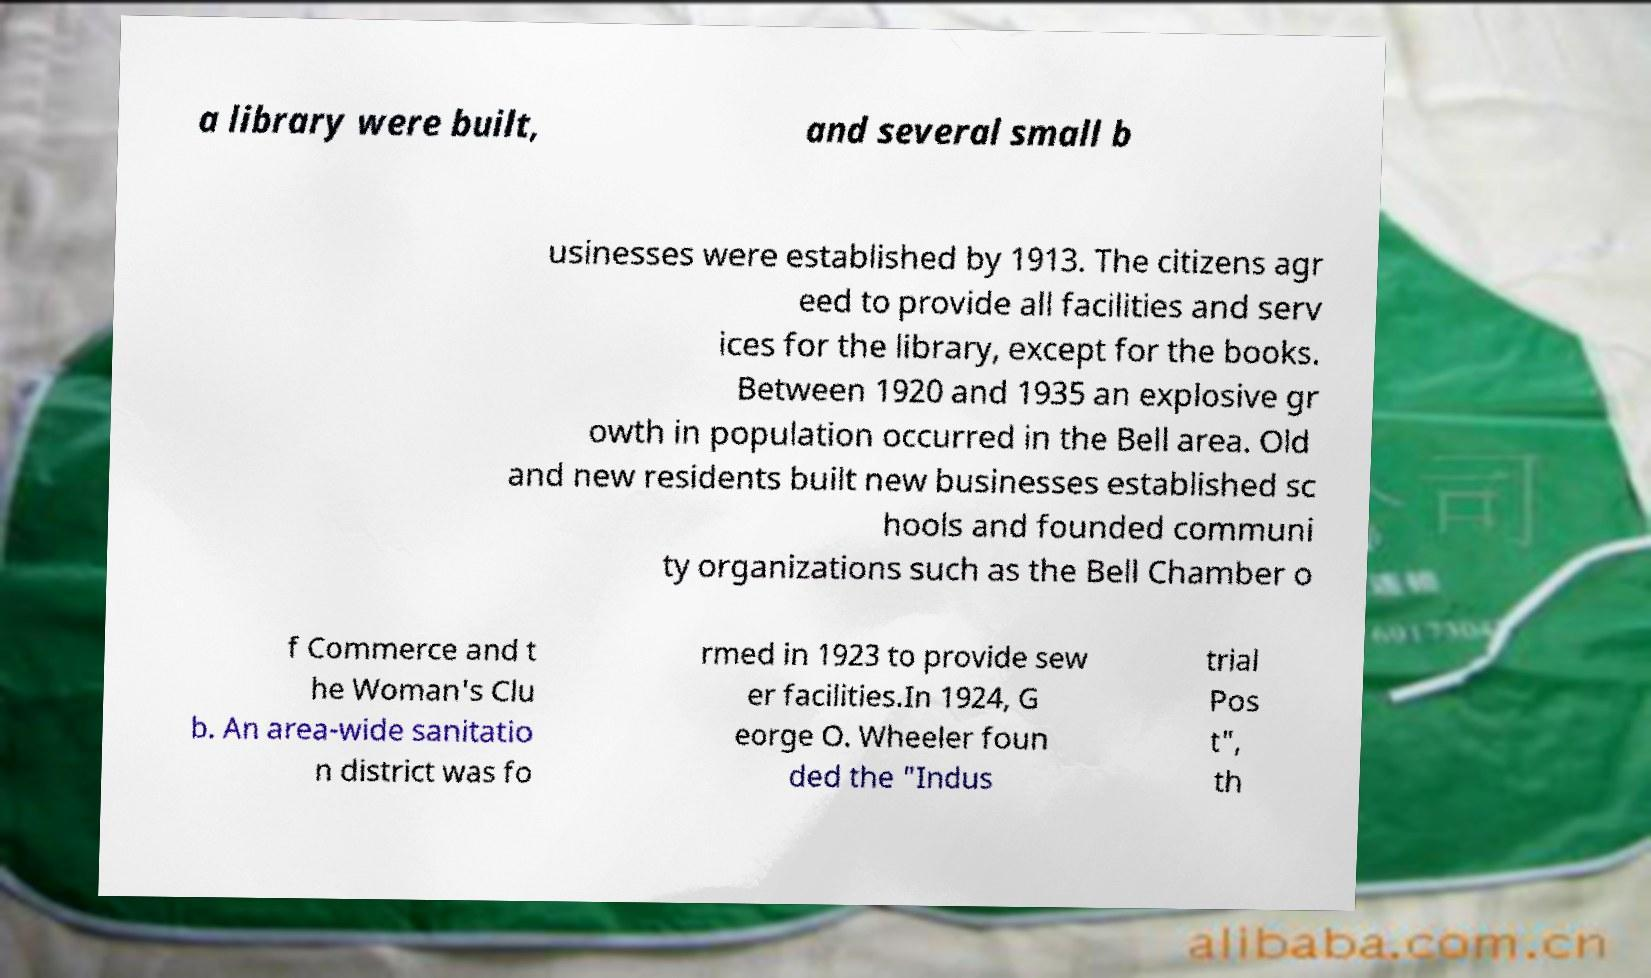Can you accurately transcribe the text from the provided image for me? a library were built, and several small b usinesses were established by 1913. The citizens agr eed to provide all facilities and serv ices for the library, except for the books. Between 1920 and 1935 an explosive gr owth in population occurred in the Bell area. Old and new residents built new businesses established sc hools and founded communi ty organizations such as the Bell Chamber o f Commerce and t he Woman's Clu b. An area-wide sanitatio n district was fo rmed in 1923 to provide sew er facilities.In 1924, G eorge O. Wheeler foun ded the "Indus trial Pos t", th 